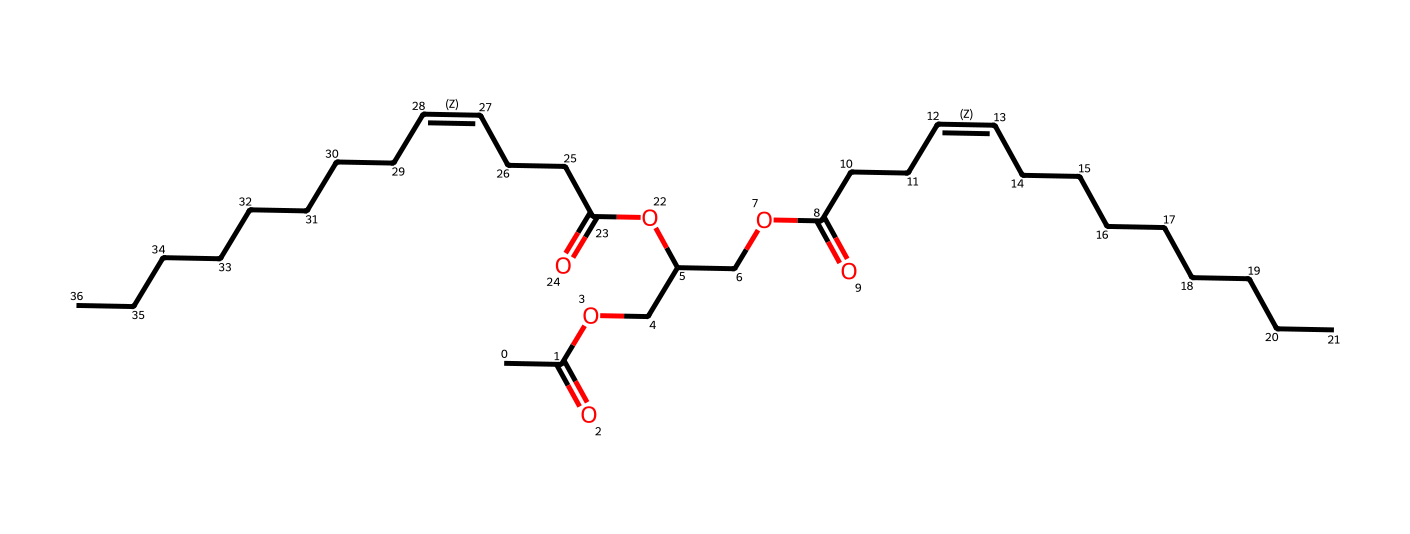What is the main functional group present in this chemical? The chemical contains functional groups like esters (evident from the -OCC and -C(=O)O groups). The presence of carbonyl and ether groups indicates that esters are the main functional group.
Answer: ester How many carbon atoms are in this structure? Counting all the carbon atoms in the structure (C), there are a total of 32 carbon atoms visible in the displayed SMILES representation.
Answer: 32 What type of hydrocarbons is represented in this compound? The presence of multiple carbon-carbon double bonds (indicated by the '/C=C\' in the structure) along with carbon chains suggests that this compound is classified as an unsaturated hydrocarbon.
Answer: unsaturated How many double bonds are present in this structure? By examining the SMILES representation, there are two locations marked by '/C=C\' that indicate the presence of two double bonds.
Answer: 2 What is the maximum number of hydrogen atoms this compound could theoretically have? The maximum number of hydrogen atoms for the given structure can be calculated based on the formula CnH(2n+2). For 32 carbon atoms, it would be 2(32) + 2 = 66. However, due to the presence of double bonds, the count will be lower, yielding 58 hydrogens in total by deducting 4 for the two double bonds.
Answer: 58 Which part of the molecule contributes to its potential medicinal properties? The ester functional groups and the long hydrocarbon chains are often linked to the properties that can interact with biological systems, which contribute to the potential medicinal properties of natural plant oils.
Answer: ester groups 